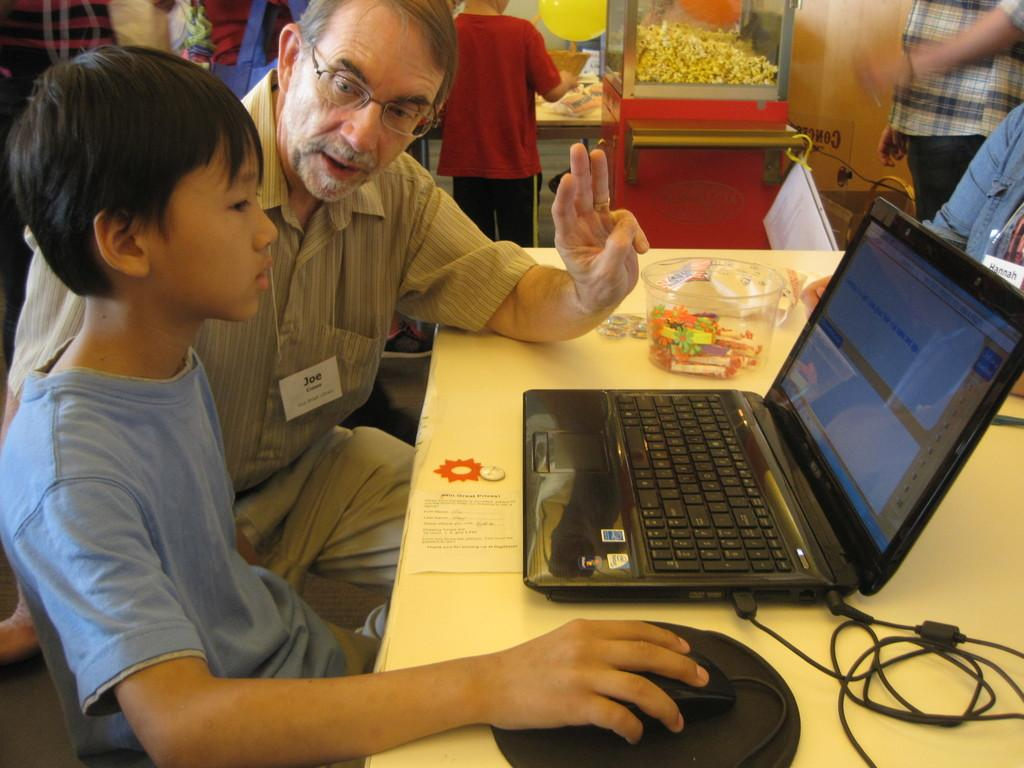Who is the main subject in the image? There is an old man in the image. What is the old man doing in the image? The old man is talking to a kid. What is the kid doing while talking to the old man? The kid is working on a laptop and using a mouse. Can you describe the background of the image? There are other people in the background of the image, and there is a popcorn machine. What type of bean is being roasted in the popcorn machine? There is no bean being roasted in the popcorn machine; it is used for making popcorn. 